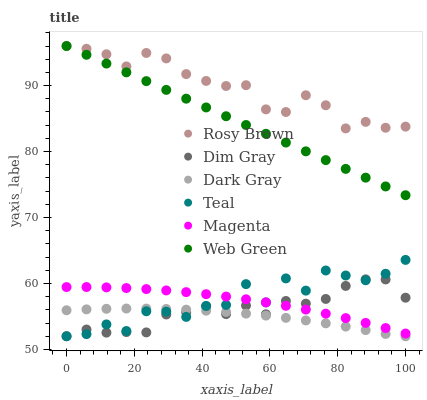Does Dark Gray have the minimum area under the curve?
Answer yes or no. Yes. Does Rosy Brown have the maximum area under the curve?
Answer yes or no. Yes. Does Web Green have the minimum area under the curve?
Answer yes or no. No. Does Web Green have the maximum area under the curve?
Answer yes or no. No. Is Web Green the smoothest?
Answer yes or no. Yes. Is Teal the roughest?
Answer yes or no. Yes. Is Rosy Brown the smoothest?
Answer yes or no. No. Is Rosy Brown the roughest?
Answer yes or no. No. Does Dim Gray have the lowest value?
Answer yes or no. Yes. Does Web Green have the lowest value?
Answer yes or no. No. Does Web Green have the highest value?
Answer yes or no. Yes. Does Dark Gray have the highest value?
Answer yes or no. No. Is Magenta less than Web Green?
Answer yes or no. Yes. Is Magenta greater than Dark Gray?
Answer yes or no. Yes. Does Dark Gray intersect Teal?
Answer yes or no. Yes. Is Dark Gray less than Teal?
Answer yes or no. No. Is Dark Gray greater than Teal?
Answer yes or no. No. Does Magenta intersect Web Green?
Answer yes or no. No. 